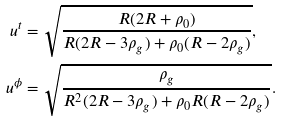<formula> <loc_0><loc_0><loc_500><loc_500>u ^ { t } & = \sqrt { \frac { R ( 2 R + \rho _ { 0 } ) } { R ( 2 R - 3 \rho _ { g } ) + \rho _ { 0 } ( R - 2 \rho _ { g } ) } } , \\ u ^ { \phi } & = \sqrt { \frac { \rho _ { g } } { R ^ { 2 } ( 2 R - 3 \rho _ { g } ) + \rho _ { 0 } R ( R - 2 \rho _ { g } ) } } .</formula> 